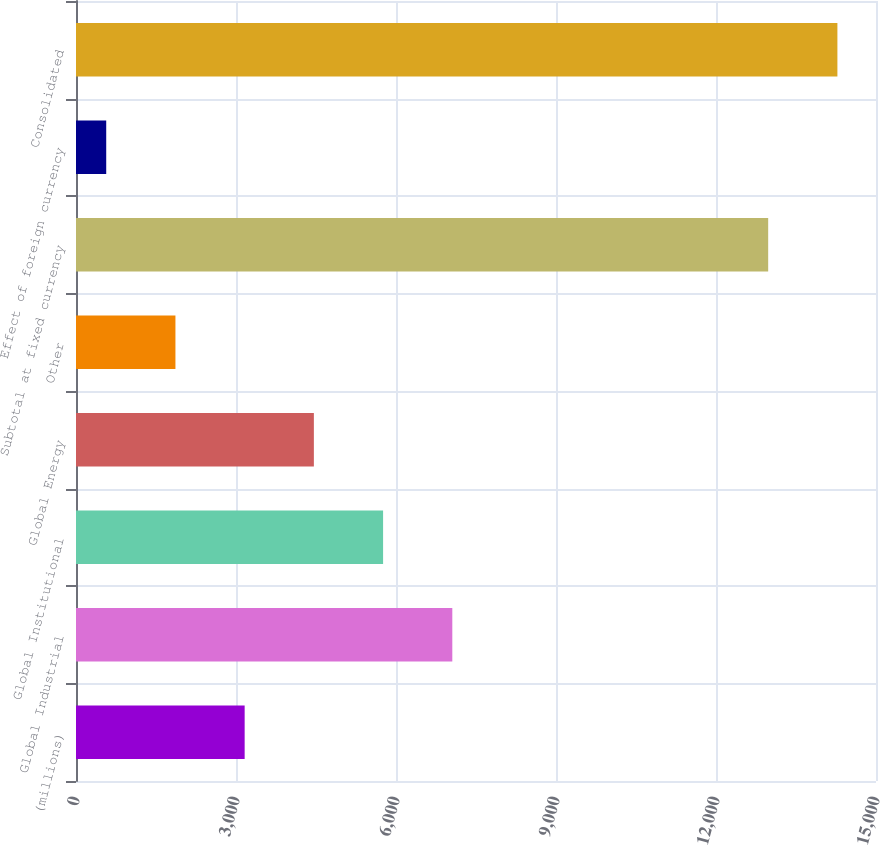Convert chart. <chart><loc_0><loc_0><loc_500><loc_500><bar_chart><fcel>(millions)<fcel>Global Industrial<fcel>Global Institutional<fcel>Global Energy<fcel>Other<fcel>Subtotal at fixed currency<fcel>Effect of foreign currency<fcel>Consolidated<nl><fcel>3162.3<fcel>7055.85<fcel>5758<fcel>4460.15<fcel>1864.45<fcel>12978.5<fcel>566.6<fcel>14276.4<nl></chart> 